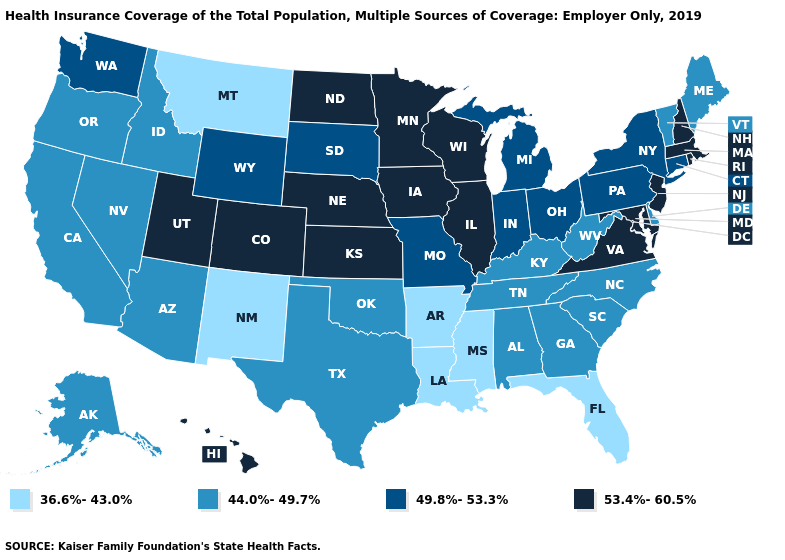What is the value of Kansas?
Quick response, please. 53.4%-60.5%. What is the lowest value in the USA?
Give a very brief answer. 36.6%-43.0%. Does the first symbol in the legend represent the smallest category?
Concise answer only. Yes. What is the highest value in the USA?
Write a very short answer. 53.4%-60.5%. How many symbols are there in the legend?
Keep it brief. 4. Does Oregon have the same value as Delaware?
Keep it brief. Yes. What is the value of South Dakota?
Keep it brief. 49.8%-53.3%. Does Wyoming have a higher value than Nebraska?
Give a very brief answer. No. What is the lowest value in the USA?
Keep it brief. 36.6%-43.0%. Which states hav the highest value in the South?
Answer briefly. Maryland, Virginia. Name the states that have a value in the range 53.4%-60.5%?
Concise answer only. Colorado, Hawaii, Illinois, Iowa, Kansas, Maryland, Massachusetts, Minnesota, Nebraska, New Hampshire, New Jersey, North Dakota, Rhode Island, Utah, Virginia, Wisconsin. What is the value of New Jersey?
Write a very short answer. 53.4%-60.5%. Does the map have missing data?
Answer briefly. No. Among the states that border Iowa , which have the lowest value?
Concise answer only. Missouri, South Dakota. What is the highest value in states that border Vermont?
Be succinct. 53.4%-60.5%. 